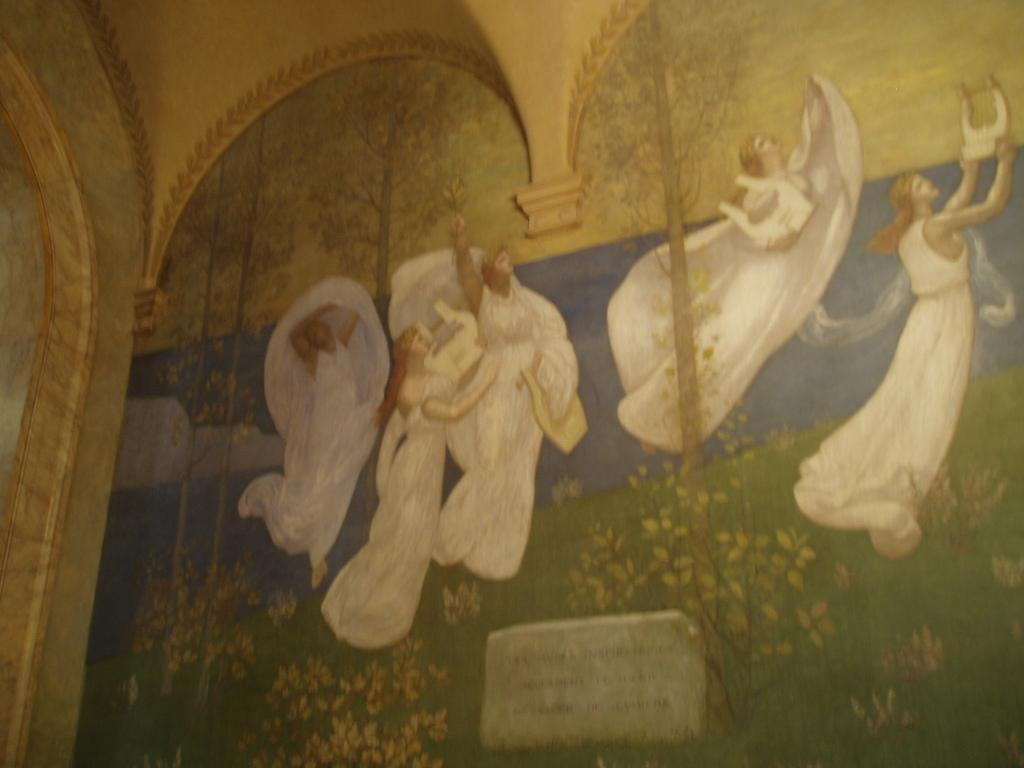Describe this image in one or two sentences. In this image, I can see the painting on the wall. There are a group of people. These are the plants and trees, which are painted on the wall. 